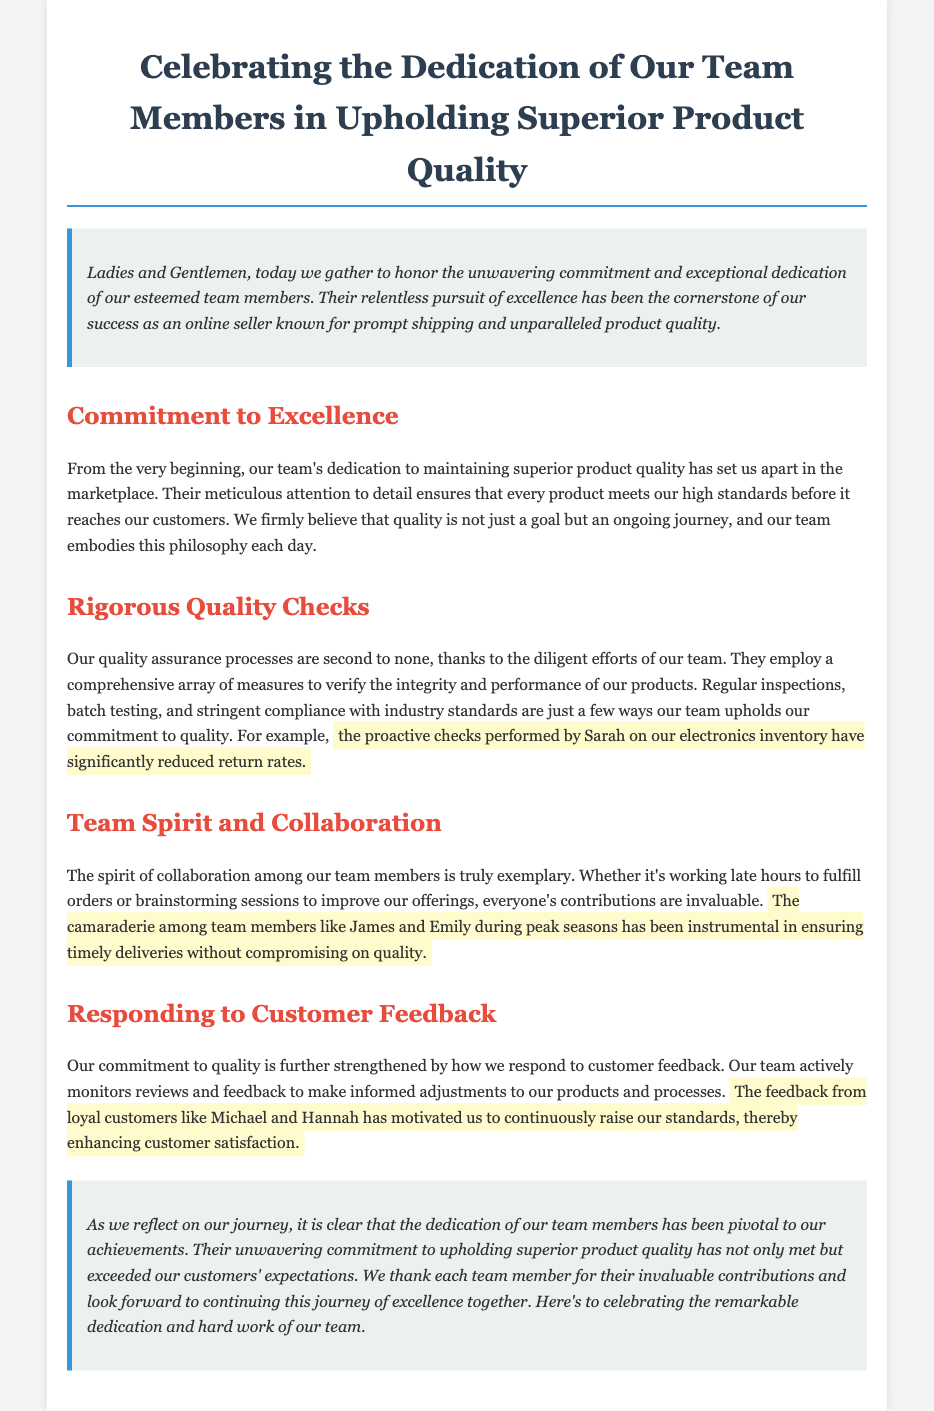What is the primary focus of the eulogy? The eulogy centers around the dedication of team members in maintaining superior product quality.
Answer: Team members' dedication in maintaining superior product quality Who significantly reduced return rates on electronics inventory? The document mentions Sarah's proactive checks as instrumental in reducing return rates.
Answer: Sarah Which two team members are highlighted for their collaboration during peak seasons? The names James and Emily are mentioned in the context of their teamwork during busy times.
Answer: James and Emily What motivates the team to continuously raise their standards? Feedback from loyal customers like Michael and Hannah serves as motivation for the team.
Answer: Feedback from Michael and Hannah How does the team ensure product integrity and performance? The team employs a range of quality assurance measures like regular inspections and batch testing.
Answer: Regular inspections and batch testing What aspect of teamwork does the eulogy emphasize? The eulogy emphasizes the spirit of collaboration among team members.
Answer: Spirit of collaboration 